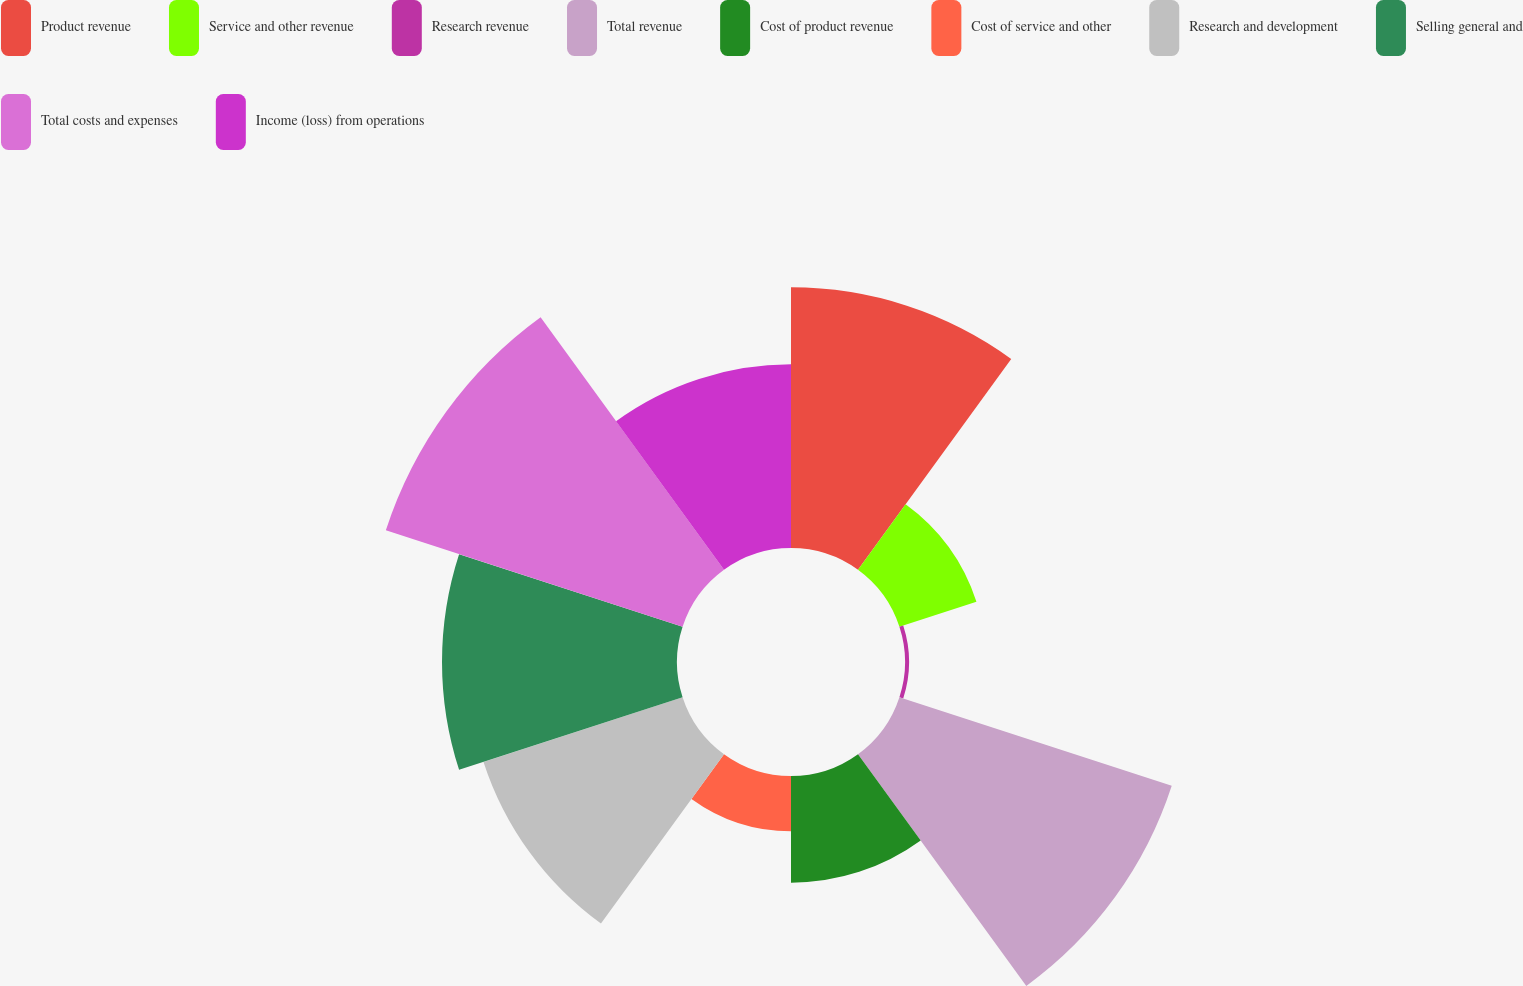Convert chart to OTSL. <chart><loc_0><loc_0><loc_500><loc_500><pie_chart><fcel>Product revenue<fcel>Service and other revenue<fcel>Research revenue<fcel>Total revenue<fcel>Cost of product revenue<fcel>Cost of service and other<fcel>Research and development<fcel>Selling general and<fcel>Total costs and expenses<fcel>Income (loss) from operations<nl><fcel>15.03%<fcel>4.67%<fcel>0.23%<fcel>16.51%<fcel>6.15%<fcel>3.19%<fcel>12.07%<fcel>13.55%<fcel>17.99%<fcel>10.59%<nl></chart> 